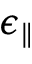Convert formula to latex. <formula><loc_0><loc_0><loc_500><loc_500>\epsilon _ { \| }</formula> 